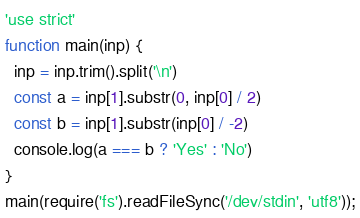<code> <loc_0><loc_0><loc_500><loc_500><_JavaScript_>'use strict'
function main(inp) {
  inp = inp.trim().split('\n')
  const a = inp[1].substr(0, inp[0] / 2)
  const b = inp[1].substr(inp[0] / -2)
  console.log(a === b ? 'Yes' : 'No')
}
main(require('fs').readFileSync('/dev/stdin', 'utf8'));
</code> 